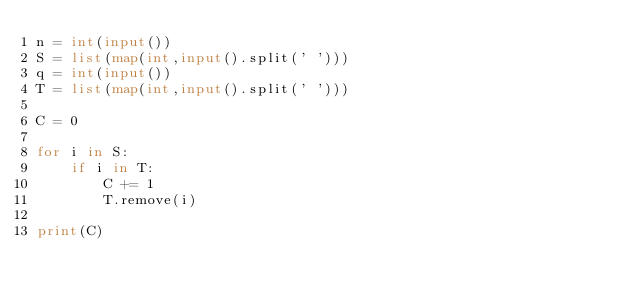<code> <loc_0><loc_0><loc_500><loc_500><_Python_>n = int(input())
S = list(map(int,input().split(' ')))
q = int(input())
T = list(map(int,input().split(' ')))

C = 0

for i in S:
    if i in T:
        C += 1
        T.remove(i)
        
print(C)

</code> 